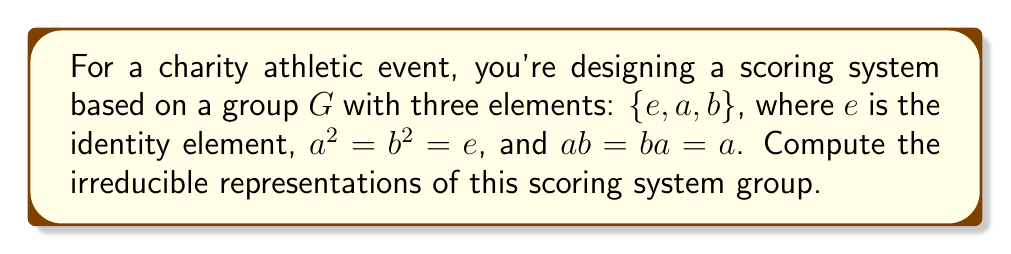Could you help me with this problem? To find the irreducible representations of this group, we'll follow these steps:

1) First, note that this group is non-abelian since $ab = a$ but $ba = b$.

2) The number of irreducible representations is equal to the number of conjugacy classes. Let's find the conjugacy classes:
   - $\{e\}$ (identity always forms its own class)
   - $\{a\}$ (conjugating $a$ by any element gives $a$)
   - $\{b\}$ (conjugating $b$ by any element gives $b$)

   So, there are 3 conjugacy classes, hence 3 irreducible representations.

3) The sum of squares of dimensions of irreducible representations equals the order of the group:

   $$d_1^2 + d_2^2 + d_3^2 = |G| = 3$$

4) Given that the group is non-abelian, we know there must be at least one 2-dimensional representation. The only possibility satisfying the equation is:

   $$1^2 + 1^2 + 1^2 = 3$$

5) Now, let's construct these representations:
   
   a) The trivial representation: $\rho_1(g) = 1$ for all $g \in G$
   
   b) The sign representation for $a$: $\rho_2(e) = 1$, $\rho_2(a) = 1$, $\rho_2(b) = -1$
   
   c) The sign representation for $b$: $\rho_3(e) = 1$, $\rho_3(a) = -1$, $\rho_3(b) = 1$

6) We can verify that these are indeed representations and that they are irreducible (since they are 1-dimensional).

Therefore, the three irreducible representations are $\rho_1$, $\rho_2$, and $\rho_3$ as described above.
Answer: $\rho_1(g) = 1$, $\rho_2(e,a,b) = (1,1,-1)$, $\rho_3(e,a,b) = (1,-1,1)$ 